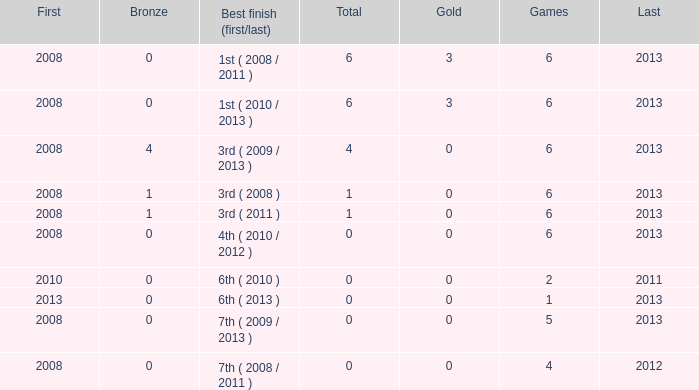What is the latest first year with 0 total medals and over 0 golds? 2008.0. 